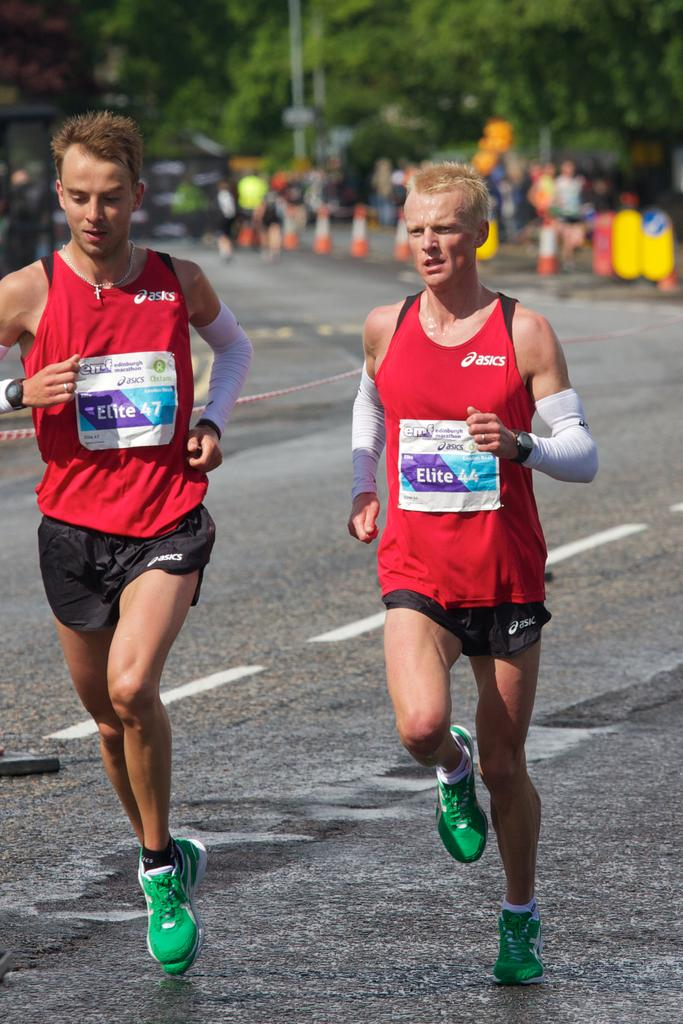<image>
Write a terse but informative summary of the picture. The two male runners are both wearing tops made by asics. 